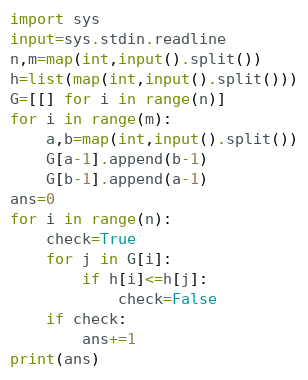Convert code to text. <code><loc_0><loc_0><loc_500><loc_500><_Python_>import sys
input=sys.stdin.readline
n,m=map(int,input().split())
h=list(map(int,input().split()))
G=[[] for i in range(n)]
for i in range(m):
    a,b=map(int,input().split())
    G[a-1].append(b-1)
    G[b-1].append(a-1)
ans=0
for i in range(n):
    check=True
    for j in G[i]:
        if h[i]<=h[j]:
            check=False
    if check:
        ans+=1
print(ans)</code> 